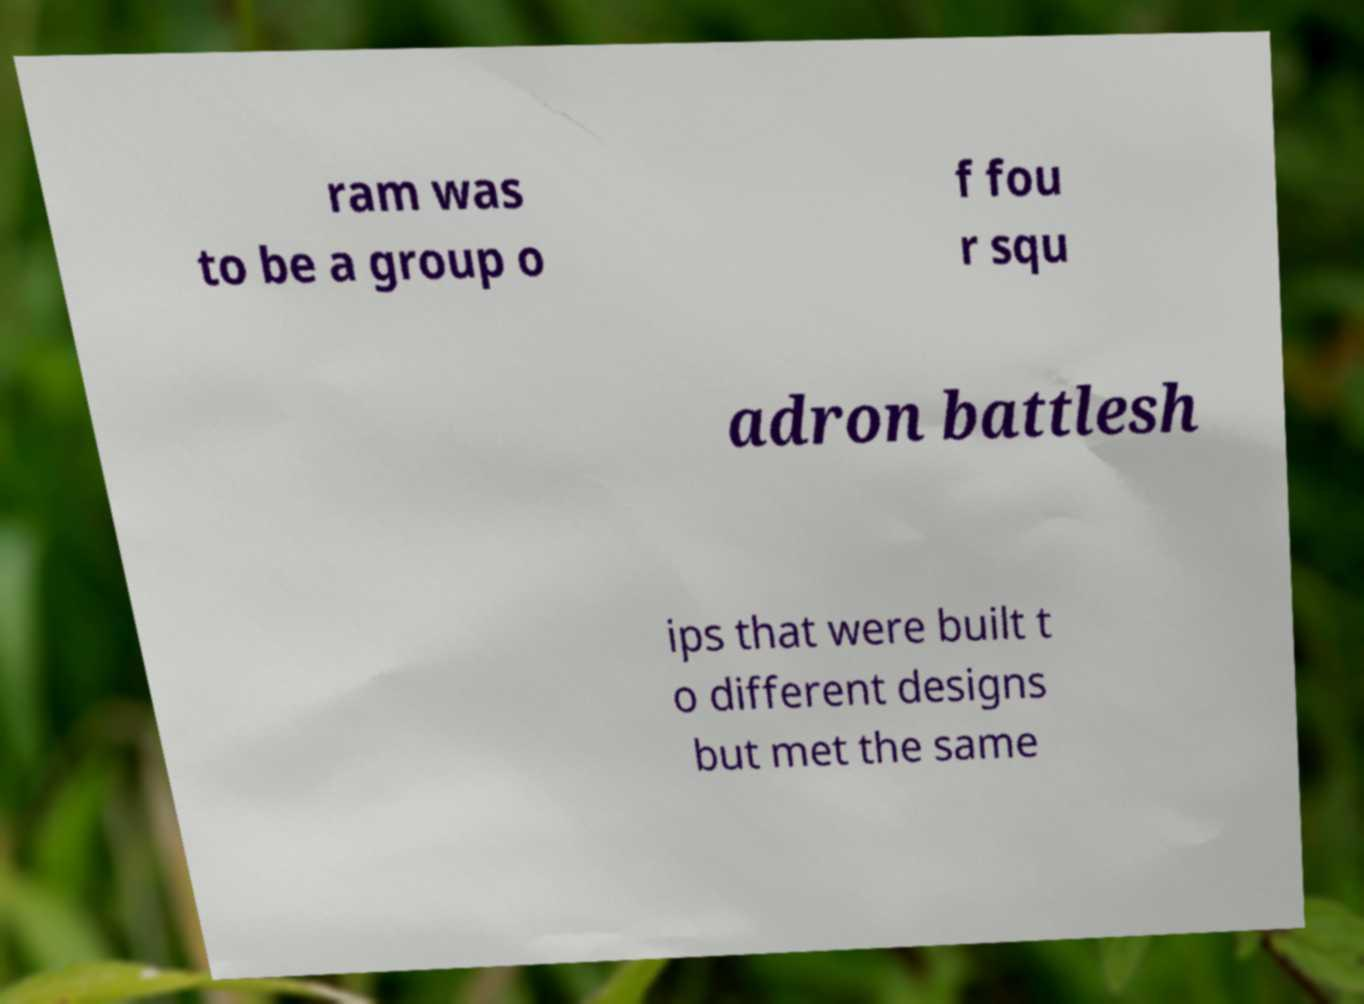Can you read and provide the text displayed in the image?This photo seems to have some interesting text. Can you extract and type it out for me? ram was to be a group o f fou r squ adron battlesh ips that were built t o different designs but met the same 